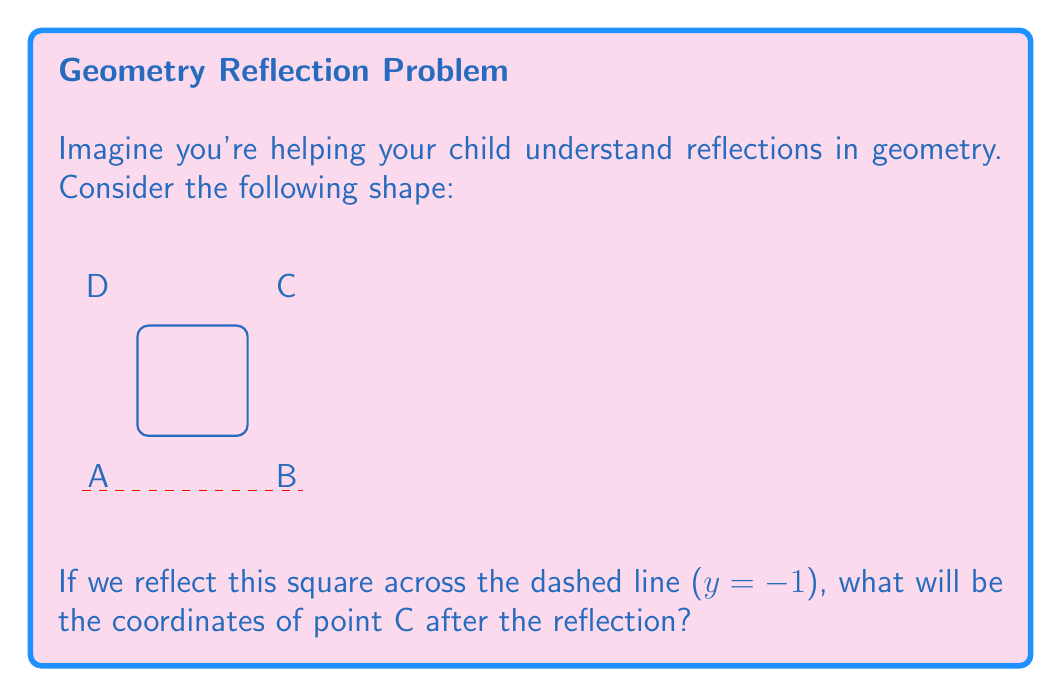Can you answer this question? Let's approach this step-by-step:

1) First, we need to understand what reflection across a horizontal line means. When we reflect a point across a horizontal line, its x-coordinate remains the same, but its y-coordinate changes.

2) The change in the y-coordinate is twice the distance between the point and the line of reflection.

3) In this case, point C has coordinates (2,2).

4) The line of reflection is y = -1.

5) To find the distance between point C and the line of reflection:
   $2 - (-1) = 3$

6) The reflected point will be this distance below the line of reflection:
   $-1 - 3 = -4$

7) Therefore, after reflection:
   - The x-coordinate remains 2
   - The new y-coordinate is -4

8) So, the coordinates of point C after reflection are (2,-4).

This concept can be generalized: for a point (x,y) reflected across the line y = k, the reflected point is (x, 2k-y).
Answer: (2,-4) 